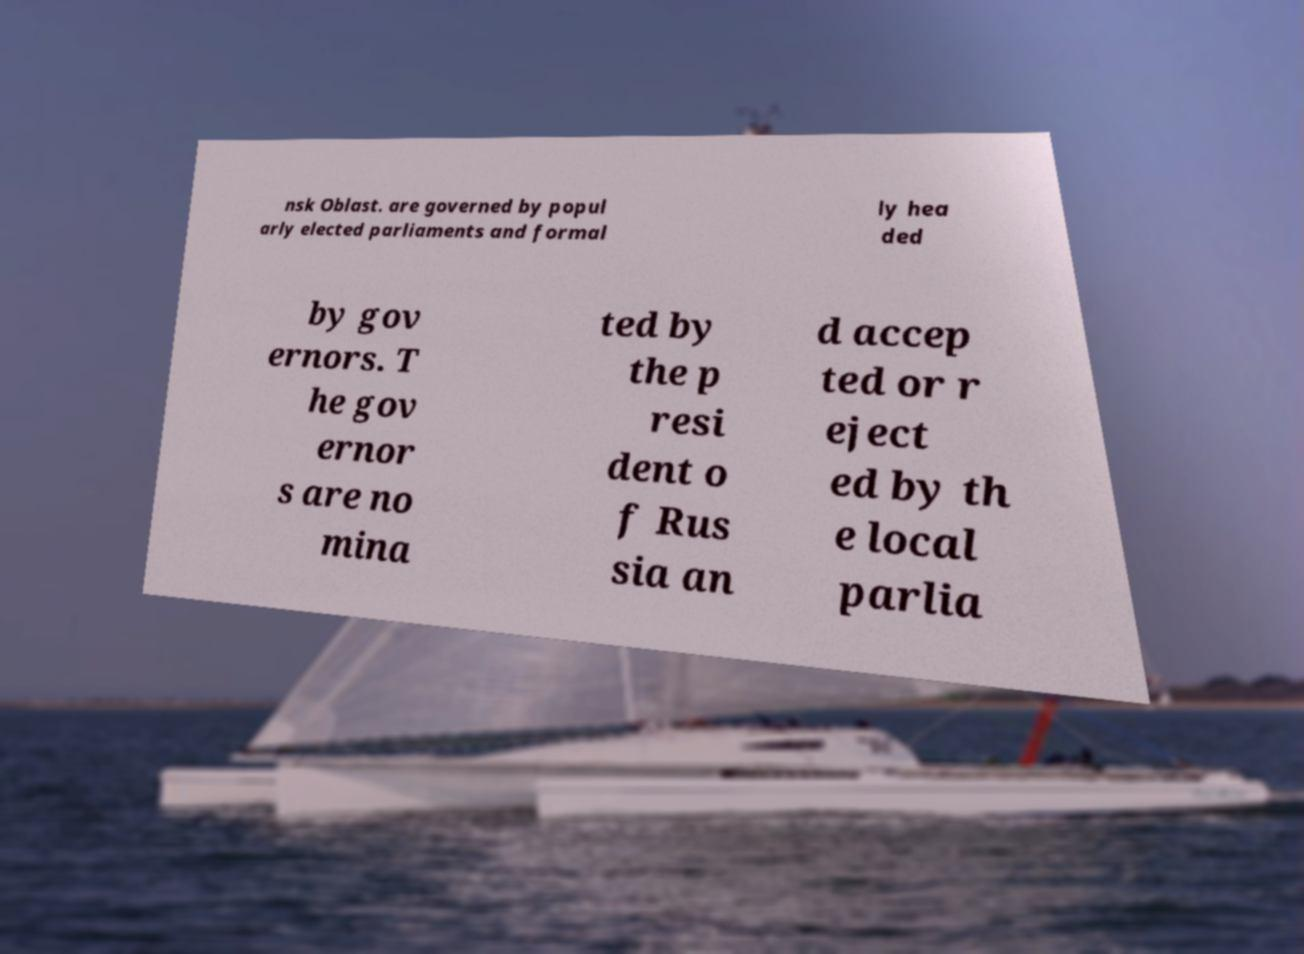I need the written content from this picture converted into text. Can you do that? nsk Oblast. are governed by popul arly elected parliaments and formal ly hea ded by gov ernors. T he gov ernor s are no mina ted by the p resi dent o f Rus sia an d accep ted or r eject ed by th e local parlia 